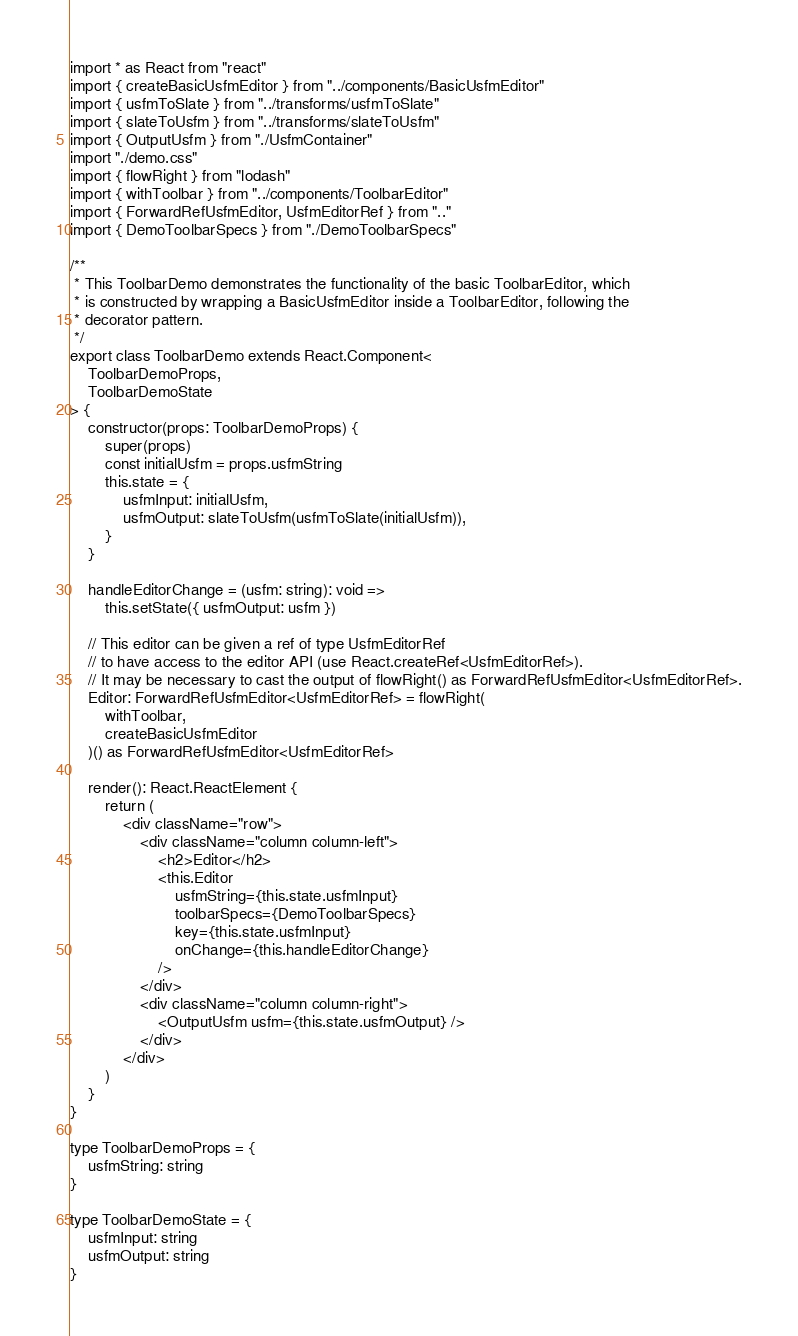<code> <loc_0><loc_0><loc_500><loc_500><_TypeScript_>import * as React from "react"
import { createBasicUsfmEditor } from "../components/BasicUsfmEditor"
import { usfmToSlate } from "../transforms/usfmToSlate"
import { slateToUsfm } from "../transforms/slateToUsfm"
import { OutputUsfm } from "./UsfmContainer"
import "./demo.css"
import { flowRight } from "lodash"
import { withToolbar } from "../components/ToolbarEditor"
import { ForwardRefUsfmEditor, UsfmEditorRef } from ".."
import { DemoToolbarSpecs } from "./DemoToolbarSpecs"

/**
 * This ToolbarDemo demonstrates the functionality of the basic ToolbarEditor, which
 * is constructed by wrapping a BasicUsfmEditor inside a ToolbarEditor, following the
 * decorator pattern.
 */
export class ToolbarDemo extends React.Component<
    ToolbarDemoProps,
    ToolbarDemoState
> {
    constructor(props: ToolbarDemoProps) {
        super(props)
        const initialUsfm = props.usfmString
        this.state = {
            usfmInput: initialUsfm,
            usfmOutput: slateToUsfm(usfmToSlate(initialUsfm)),
        }
    }

    handleEditorChange = (usfm: string): void =>
        this.setState({ usfmOutput: usfm })

    // This editor can be given a ref of type UsfmEditorRef
    // to have access to the editor API (use React.createRef<UsfmEditorRef>).
    // It may be necessary to cast the output of flowRight() as ForwardRefUsfmEditor<UsfmEditorRef>.
    Editor: ForwardRefUsfmEditor<UsfmEditorRef> = flowRight(
        withToolbar,
        createBasicUsfmEditor
    )() as ForwardRefUsfmEditor<UsfmEditorRef>

    render(): React.ReactElement {
        return (
            <div className="row">
                <div className="column column-left">
                    <h2>Editor</h2>
                    <this.Editor
                        usfmString={this.state.usfmInput}
                        toolbarSpecs={DemoToolbarSpecs}
                        key={this.state.usfmInput}
                        onChange={this.handleEditorChange}
                    />
                </div>
                <div className="column column-right">
                    <OutputUsfm usfm={this.state.usfmOutput} />
                </div>
            </div>
        )
    }
}

type ToolbarDemoProps = {
    usfmString: string
}

type ToolbarDemoState = {
    usfmInput: string
    usfmOutput: string
}
</code> 